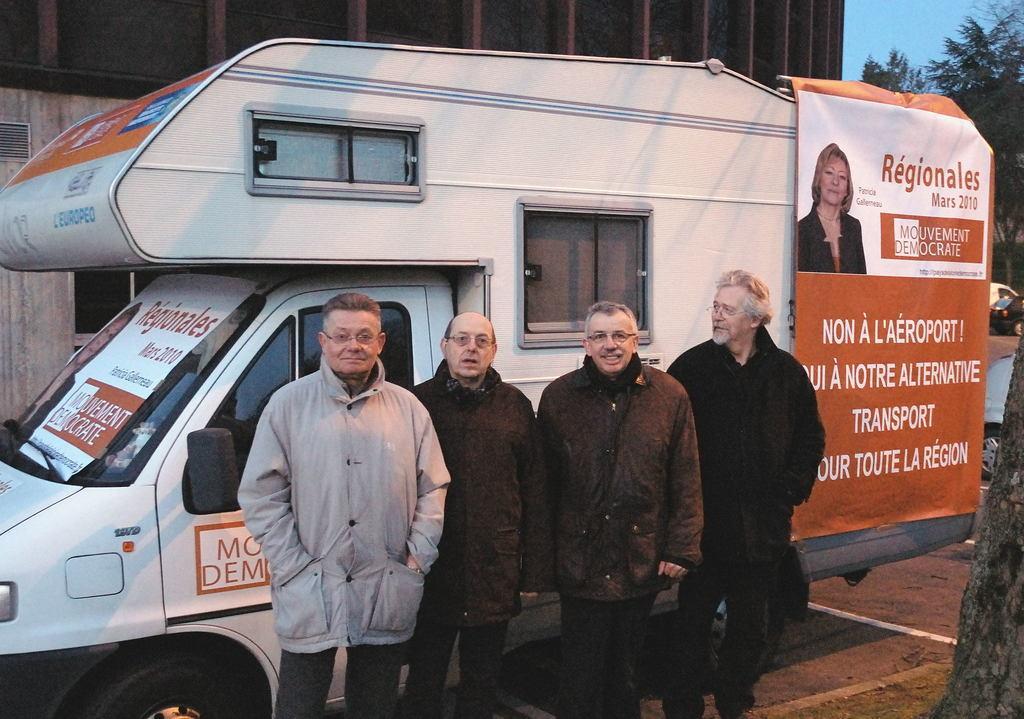Can you describe this image briefly? In this image I can see four people standing in-front of the vehicle. These people are wearing the different color dresses. And I can see the banner is attached to the vehicle. In the back I can see the building, trees and the blue sky. 